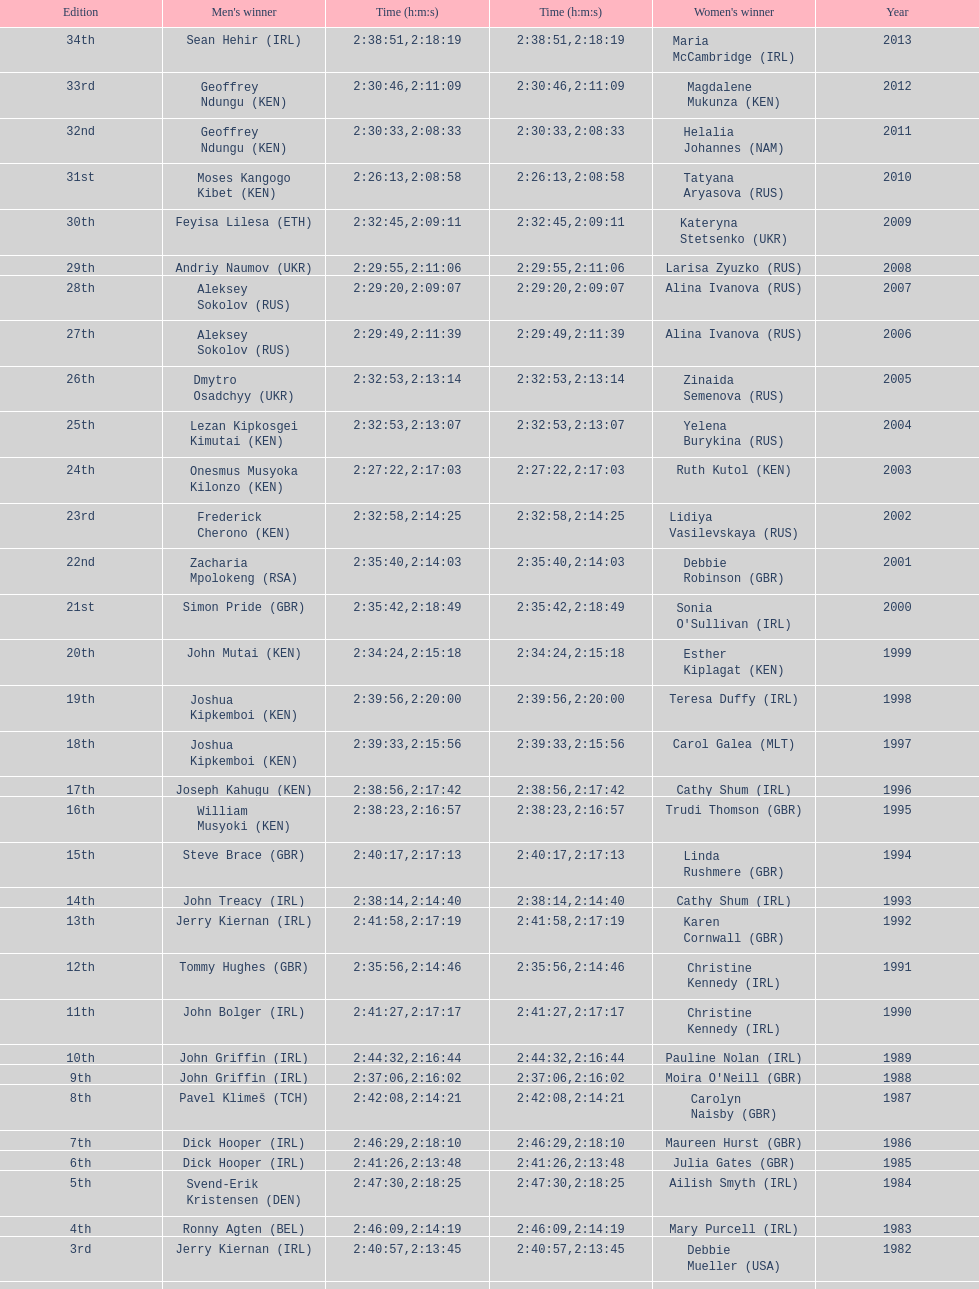Would you mind parsing the complete table? {'header': ['Edition', "Men's winner", 'Time (h:m:s)', 'Time (h:m:s)', "Women's winner", 'Year'], 'rows': [['34th', 'Sean Hehir\xa0(IRL)', '2:38:51', '2:18:19', 'Maria McCambridge\xa0(IRL)', '2013'], ['33rd', 'Geoffrey Ndungu\xa0(KEN)', '2:30:46', '2:11:09', 'Magdalene Mukunza\xa0(KEN)', '2012'], ['32nd', 'Geoffrey Ndungu\xa0(KEN)', '2:30:33', '2:08:33', 'Helalia Johannes\xa0(NAM)', '2011'], ['31st', 'Moses Kangogo Kibet\xa0(KEN)', '2:26:13', '2:08:58', 'Tatyana Aryasova\xa0(RUS)', '2010'], ['30th', 'Feyisa Lilesa\xa0(ETH)', '2:32:45', '2:09:11', 'Kateryna Stetsenko\xa0(UKR)', '2009'], ['29th', 'Andriy Naumov\xa0(UKR)', '2:29:55', '2:11:06', 'Larisa Zyuzko\xa0(RUS)', '2008'], ['28th', 'Aleksey Sokolov\xa0(RUS)', '2:29:20', '2:09:07', 'Alina Ivanova\xa0(RUS)', '2007'], ['27th', 'Aleksey Sokolov\xa0(RUS)', '2:29:49', '2:11:39', 'Alina Ivanova\xa0(RUS)', '2006'], ['26th', 'Dmytro Osadchyy\xa0(UKR)', '2:32:53', '2:13:14', 'Zinaida Semenova\xa0(RUS)', '2005'], ['25th', 'Lezan Kipkosgei Kimutai\xa0(KEN)', '2:32:53', '2:13:07', 'Yelena Burykina\xa0(RUS)', '2004'], ['24th', 'Onesmus Musyoka Kilonzo\xa0(KEN)', '2:27:22', '2:17:03', 'Ruth Kutol\xa0(KEN)', '2003'], ['23rd', 'Frederick Cherono\xa0(KEN)', '2:32:58', '2:14:25', 'Lidiya Vasilevskaya\xa0(RUS)', '2002'], ['22nd', 'Zacharia Mpolokeng\xa0(RSA)', '2:35:40', '2:14:03', 'Debbie Robinson\xa0(GBR)', '2001'], ['21st', 'Simon Pride\xa0(GBR)', '2:35:42', '2:18:49', "Sonia O'Sullivan\xa0(IRL)", '2000'], ['20th', 'John Mutai\xa0(KEN)', '2:34:24', '2:15:18', 'Esther Kiplagat\xa0(KEN)', '1999'], ['19th', 'Joshua Kipkemboi\xa0(KEN)', '2:39:56', '2:20:00', 'Teresa Duffy\xa0(IRL)', '1998'], ['18th', 'Joshua Kipkemboi\xa0(KEN)', '2:39:33', '2:15:56', 'Carol Galea\xa0(MLT)', '1997'], ['17th', 'Joseph Kahugu\xa0(KEN)', '2:38:56', '2:17:42', 'Cathy Shum\xa0(IRL)', '1996'], ['16th', 'William Musyoki\xa0(KEN)', '2:38:23', '2:16:57', 'Trudi Thomson\xa0(GBR)', '1995'], ['15th', 'Steve Brace\xa0(GBR)', '2:40:17', '2:17:13', 'Linda Rushmere\xa0(GBR)', '1994'], ['14th', 'John Treacy\xa0(IRL)', '2:38:14', '2:14:40', 'Cathy Shum\xa0(IRL)', '1993'], ['13th', 'Jerry Kiernan\xa0(IRL)', '2:41:58', '2:17:19', 'Karen Cornwall\xa0(GBR)', '1992'], ['12th', 'Tommy Hughes\xa0(GBR)', '2:35:56', '2:14:46', 'Christine Kennedy\xa0(IRL)', '1991'], ['11th', 'John Bolger\xa0(IRL)', '2:41:27', '2:17:17', 'Christine Kennedy\xa0(IRL)', '1990'], ['10th', 'John Griffin\xa0(IRL)', '2:44:32', '2:16:44', 'Pauline Nolan\xa0(IRL)', '1989'], ['9th', 'John Griffin\xa0(IRL)', '2:37:06', '2:16:02', "Moira O'Neill\xa0(GBR)", '1988'], ['8th', 'Pavel Klimeš\xa0(TCH)', '2:42:08', '2:14:21', 'Carolyn Naisby\xa0(GBR)', '1987'], ['7th', 'Dick Hooper\xa0(IRL)', '2:46:29', '2:18:10', 'Maureen Hurst\xa0(GBR)', '1986'], ['6th', 'Dick Hooper\xa0(IRL)', '2:41:26', '2:13:48', 'Julia Gates\xa0(GBR)', '1985'], ['5th', 'Svend-Erik Kristensen\xa0(DEN)', '2:47:30', '2:18:25', 'Ailish Smyth\xa0(IRL)', '1984'], ['4th', 'Ronny Agten\xa0(BEL)', '2:46:09', '2:14:19', 'Mary Purcell\xa0(IRL)', '1983'], ['3rd', 'Jerry Kiernan\xa0(IRL)', '2:40:57', '2:13:45', 'Debbie Mueller\xa0(USA)', '1982'], ['2nd', 'Neil Cusack\xa0(IRL)', '2:48:22', '2:13:58', 'Emily Dowling\xa0(IRL)', '1981'], ['1st', 'Dick Hooper\xa0(IRL)', '2:42:11', '2:16:14', 'Carey May\xa0(IRL)', '1980']]} Who won at least 3 times in the mens? Dick Hooper (IRL). 